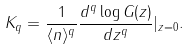Convert formula to latex. <formula><loc_0><loc_0><loc_500><loc_500>K _ { q } = \frac { 1 } { \langle n \rangle ^ { q } } \frac { d ^ { q } \log G ( z ) } { d z ^ { q } } | _ { z = 0 } .</formula> 